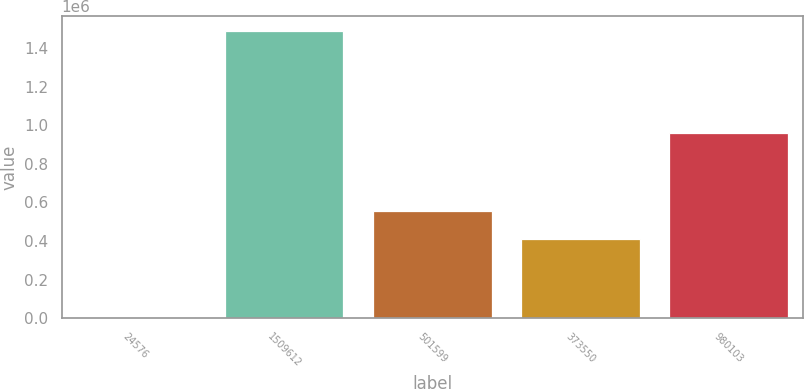Convert chart. <chart><loc_0><loc_0><loc_500><loc_500><bar_chart><fcel>24576<fcel>1509612<fcel>501599<fcel>373550<fcel>980103<nl><fcel>4211<fcel>1.48925e+06<fcel>556219<fcel>407715<fcel>959738<nl></chart> 